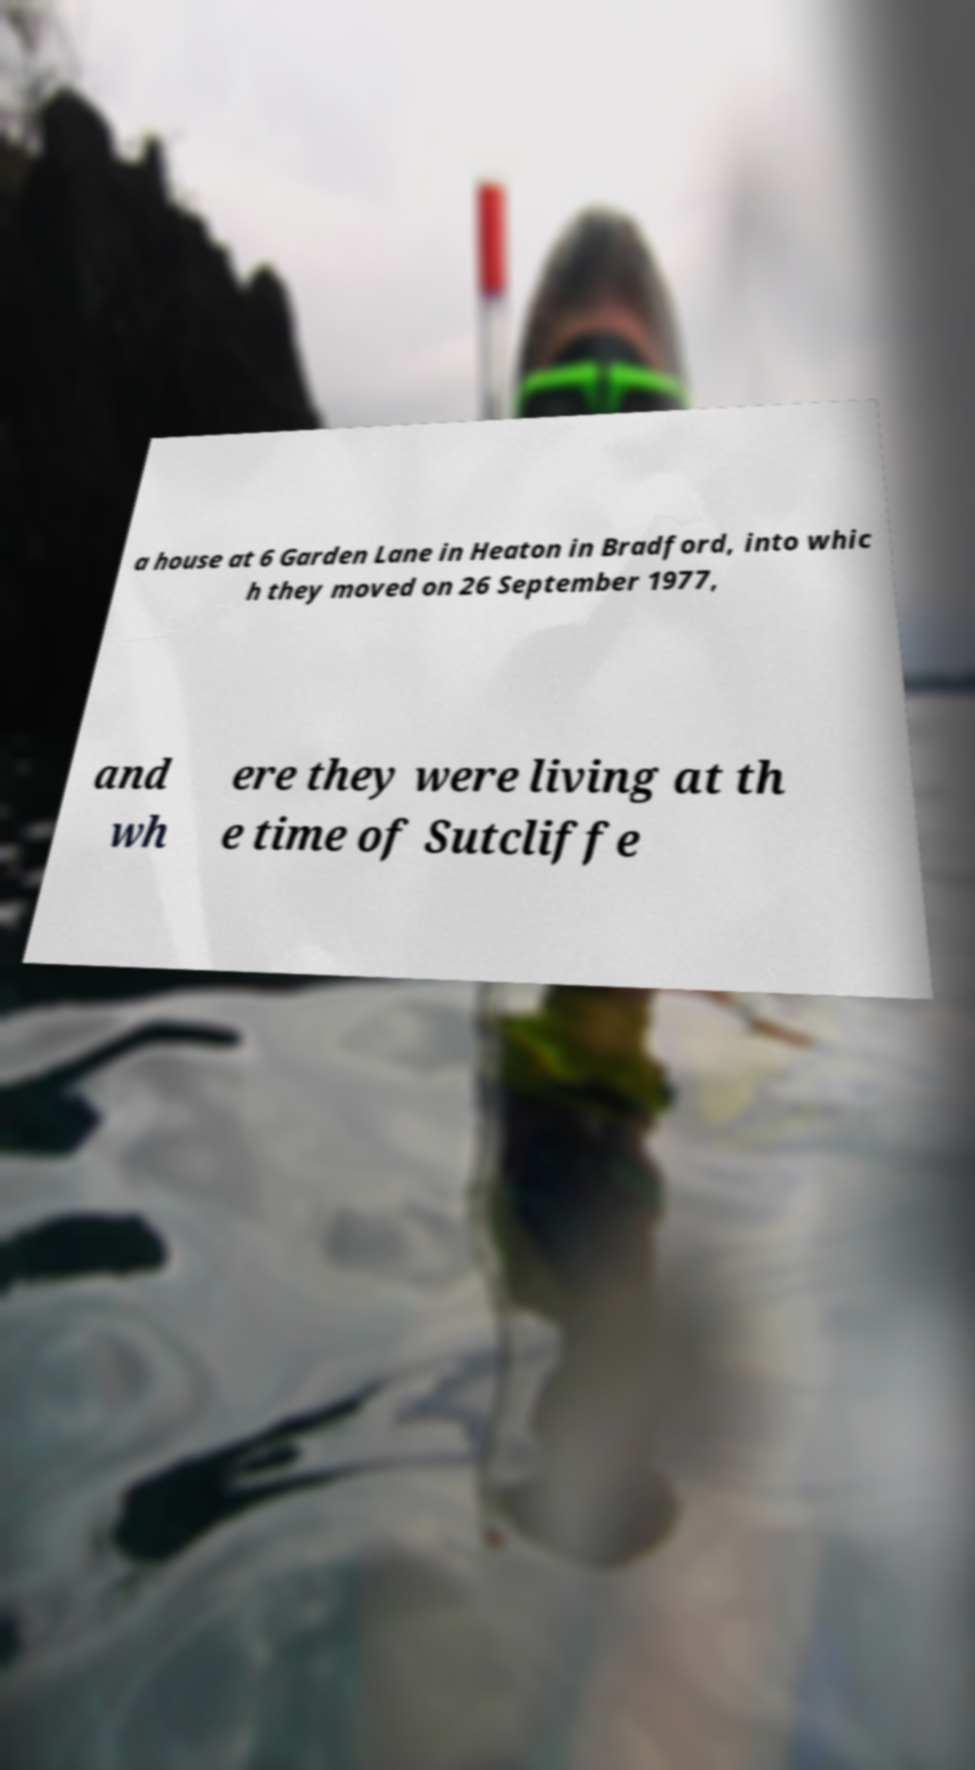Please identify and transcribe the text found in this image. a house at 6 Garden Lane in Heaton in Bradford, into whic h they moved on 26 September 1977, and wh ere they were living at th e time of Sutcliffe 